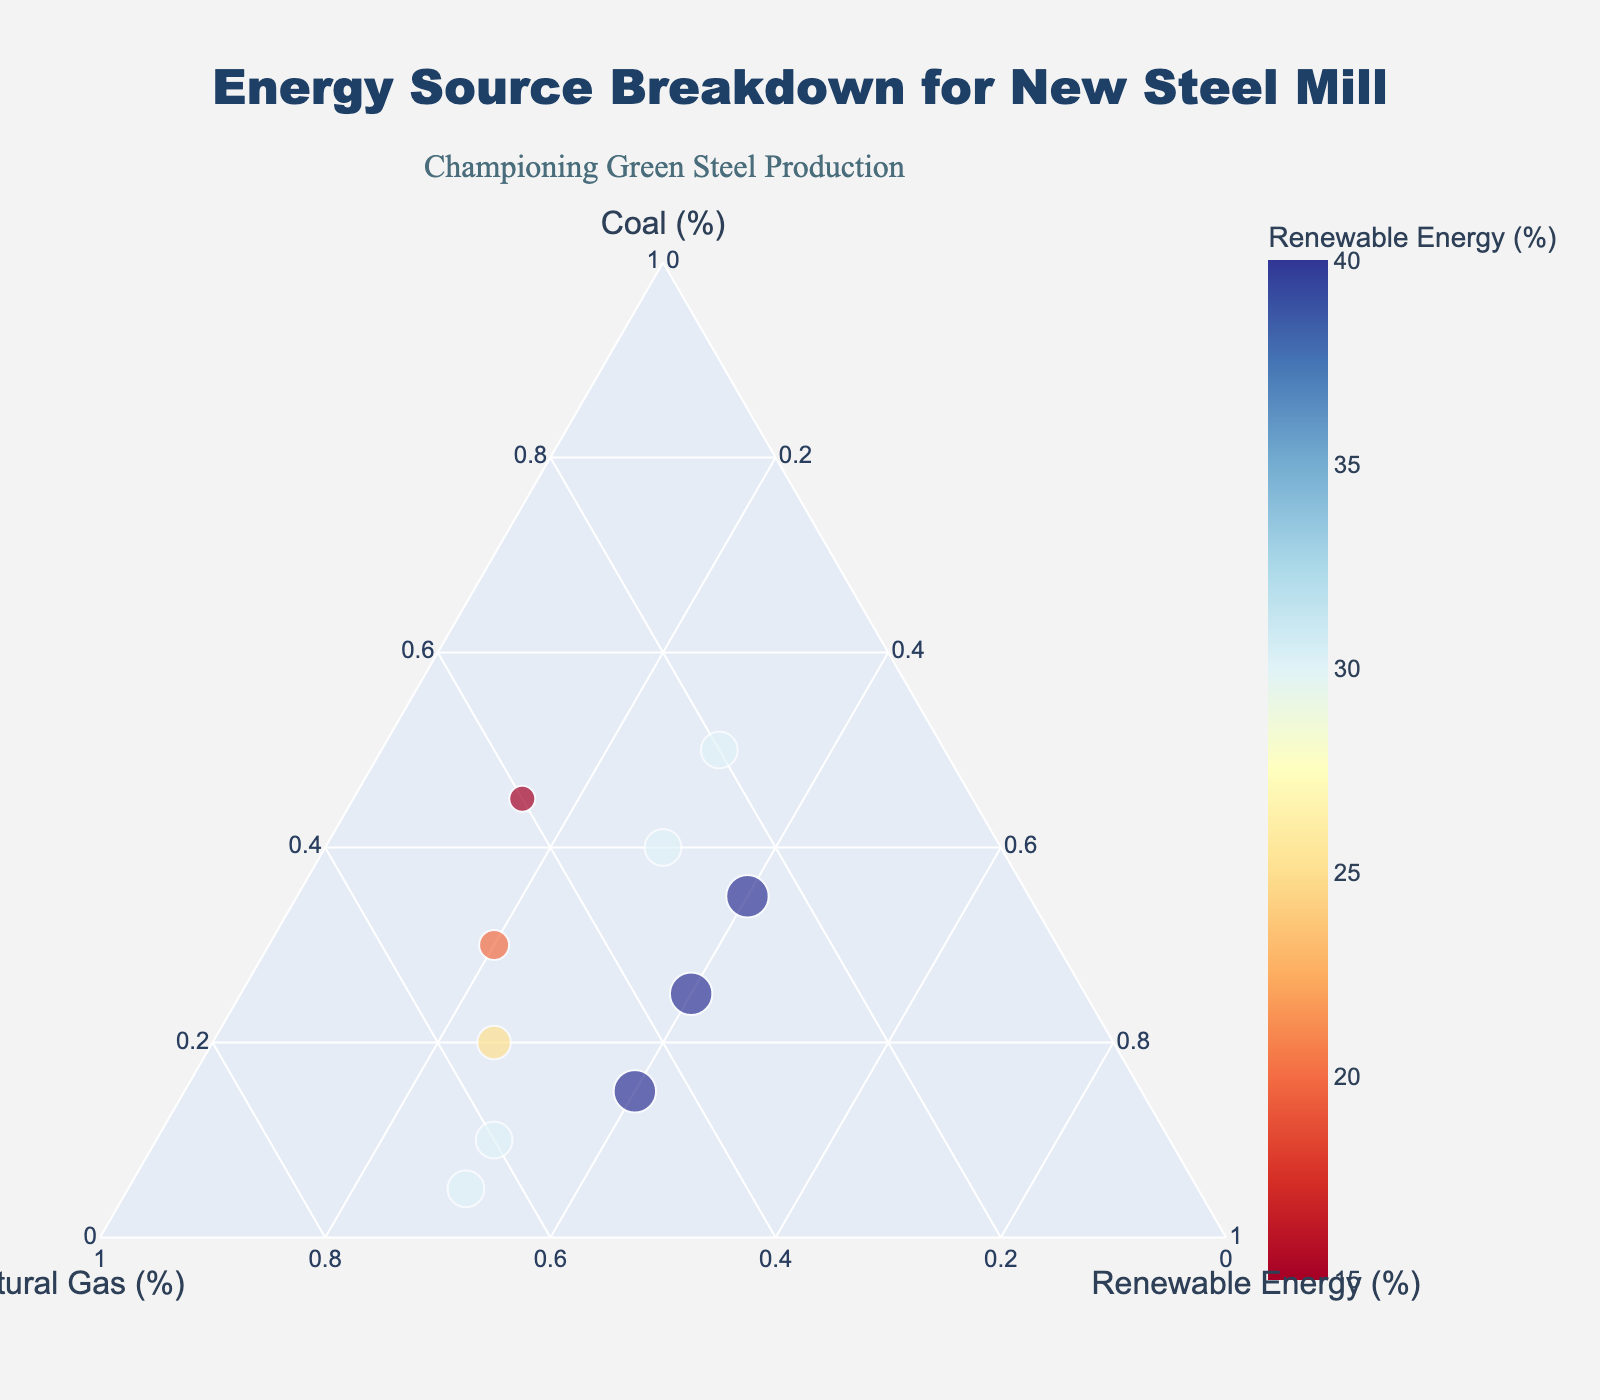What's the title of the figure? The title is usually placed at the top of the figure in a readable font and size. Here, it reads "Energy Source Breakdown for New Steel Mill".
Answer: Energy Source Breakdown for New Steel Mill Which axis represents the percentage of Coal? In a ternary plot, each side of the triangle represents a different variable. The label "Coal (%)" appears at one axis.
Answer: Coal How many data points are plotted in the figure? Each data point is marked by a scatter point in the ternary diagram. Counting these points, we find there are 10 in total.
Answer: 10 What color scale is used to represent Renewable Energy? The color scale in use is continuous and changes from one color to another based on the values of Renewable Energy. Here, the color scale is diverging and goes from red to blue.
Answer: Red to Blue Which data point has the highest percentage of Natural Gas? The data point with the highest percentage of Natural Gas will be positioned closest to the Natural Gas axis. Here, the point (5, 65, 30) marks the highest Natural Gas percentage at 65%.
Answer: 65% What is the median value of Renewable Energy across all data points? To find the median, we list out the Renewable Energy values (15, 20, 25, 30, 30, 30, 40, 40, 40, 30) and identify the middle value(s). With 10 values, the median is the average of the 5th and 6th values.
Answer: 30% Which energy source has the most pronounced decrease among the data points? By examining the movement of data points in the ternary plot, we can see which side of the triangle has the steepest decrease. Here, Coal shows the most pronounced decrease.
Answer: Coal What is the greatest proportion of Renewable Energy in the data points, and what other proportions are associated with this data point? The highest percentage of Renewable Energy, according to the scatter sizes and color scale, is 40%. This is found in points (15, 45, 40), (25, 35, 40), and (35, 25, 40).
Answer: 40%, associated with multiple points Compare the data point with 45% Coal with the data point having 5% coal. Which one has more Renewable Energy? We compare the Renewable Energy percentages of the points (45, 40, 15) and (5, 65, 30). The point with 5% Coal has 30% Renewable Energy, which is higher than the 15% Renewable Energy at 45% Coal.
Answer: The data point with 5% Coal What relationship can be inferred between Coal percentage and Renewable Energy percentage? Examining the placement and general location of data points, we observe that as the percentage of Coal decreases, the percentage of Renewable Energy tends to increase.
Answer: Inversely related 